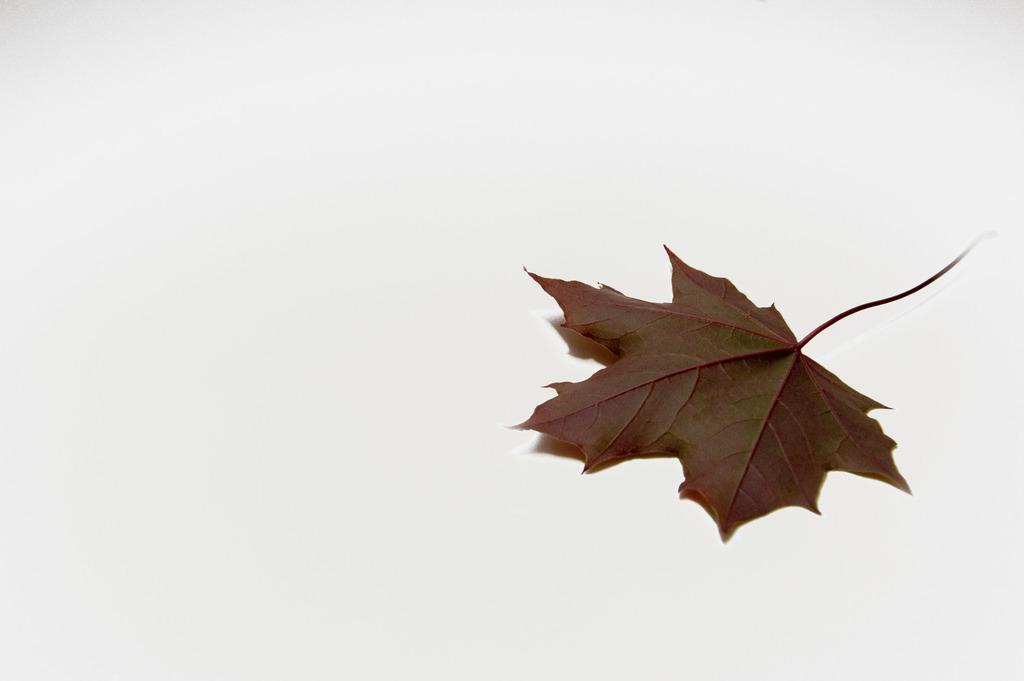Can you describe this image briefly? This image consists of a leaf in brown color is kept on the floor. The background is white in color. 